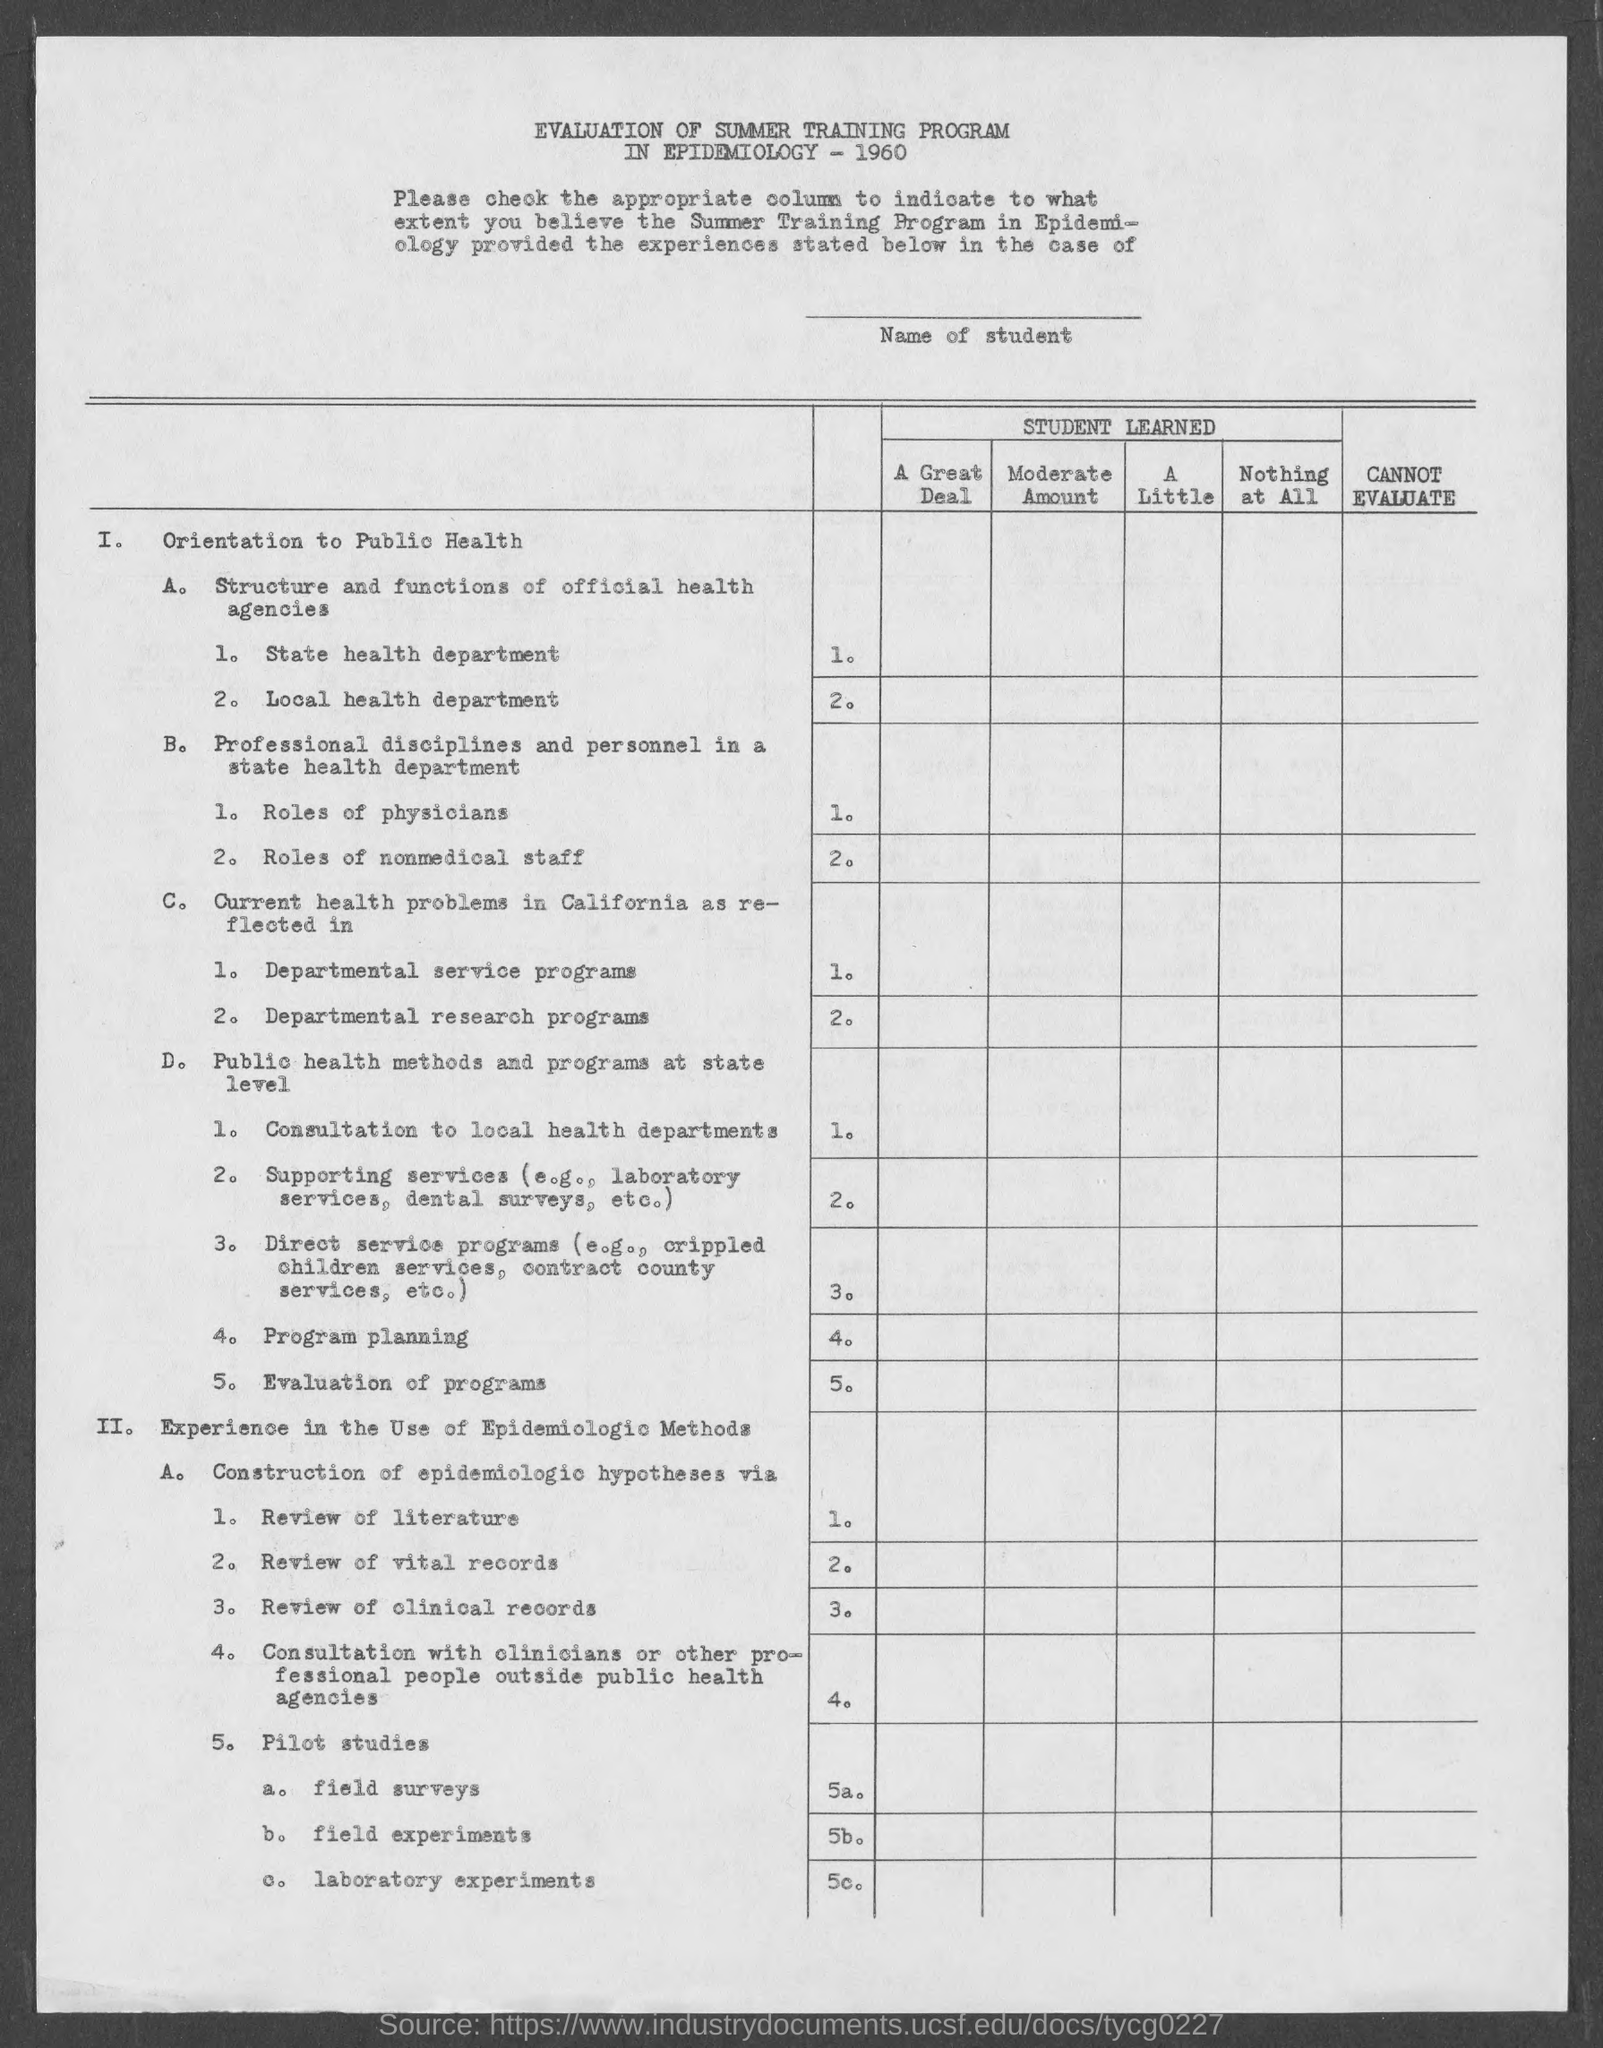Evaluation of summer training program in epidemiology belongs to which year?
Give a very brief answer. 1960. 